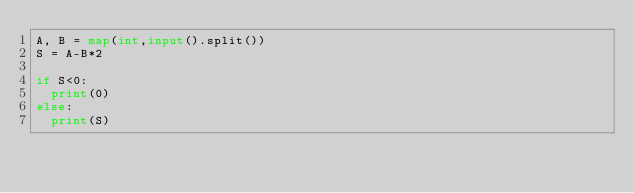Convert code to text. <code><loc_0><loc_0><loc_500><loc_500><_Python_>A, B = map(int,input().split())
S = A-B*2

if S<0:
  print(0)
else:
  print(S)</code> 